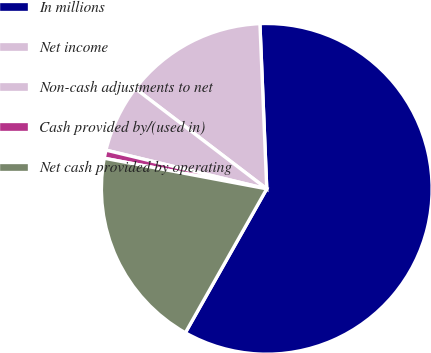Convert chart to OTSL. <chart><loc_0><loc_0><loc_500><loc_500><pie_chart><fcel>In millions<fcel>Net income<fcel>Non-cash adjustments to net<fcel>Cash provided by/(used in)<fcel>Net cash provided by operating<nl><fcel>58.85%<fcel>13.97%<fcel>6.61%<fcel>0.8%<fcel>19.77%<nl></chart> 